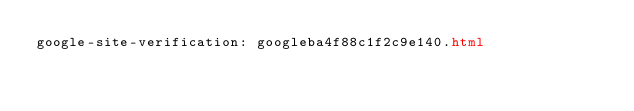Convert code to text. <code><loc_0><loc_0><loc_500><loc_500><_HTML_>google-site-verification: googleba4f88c1f2c9e140.html</code> 